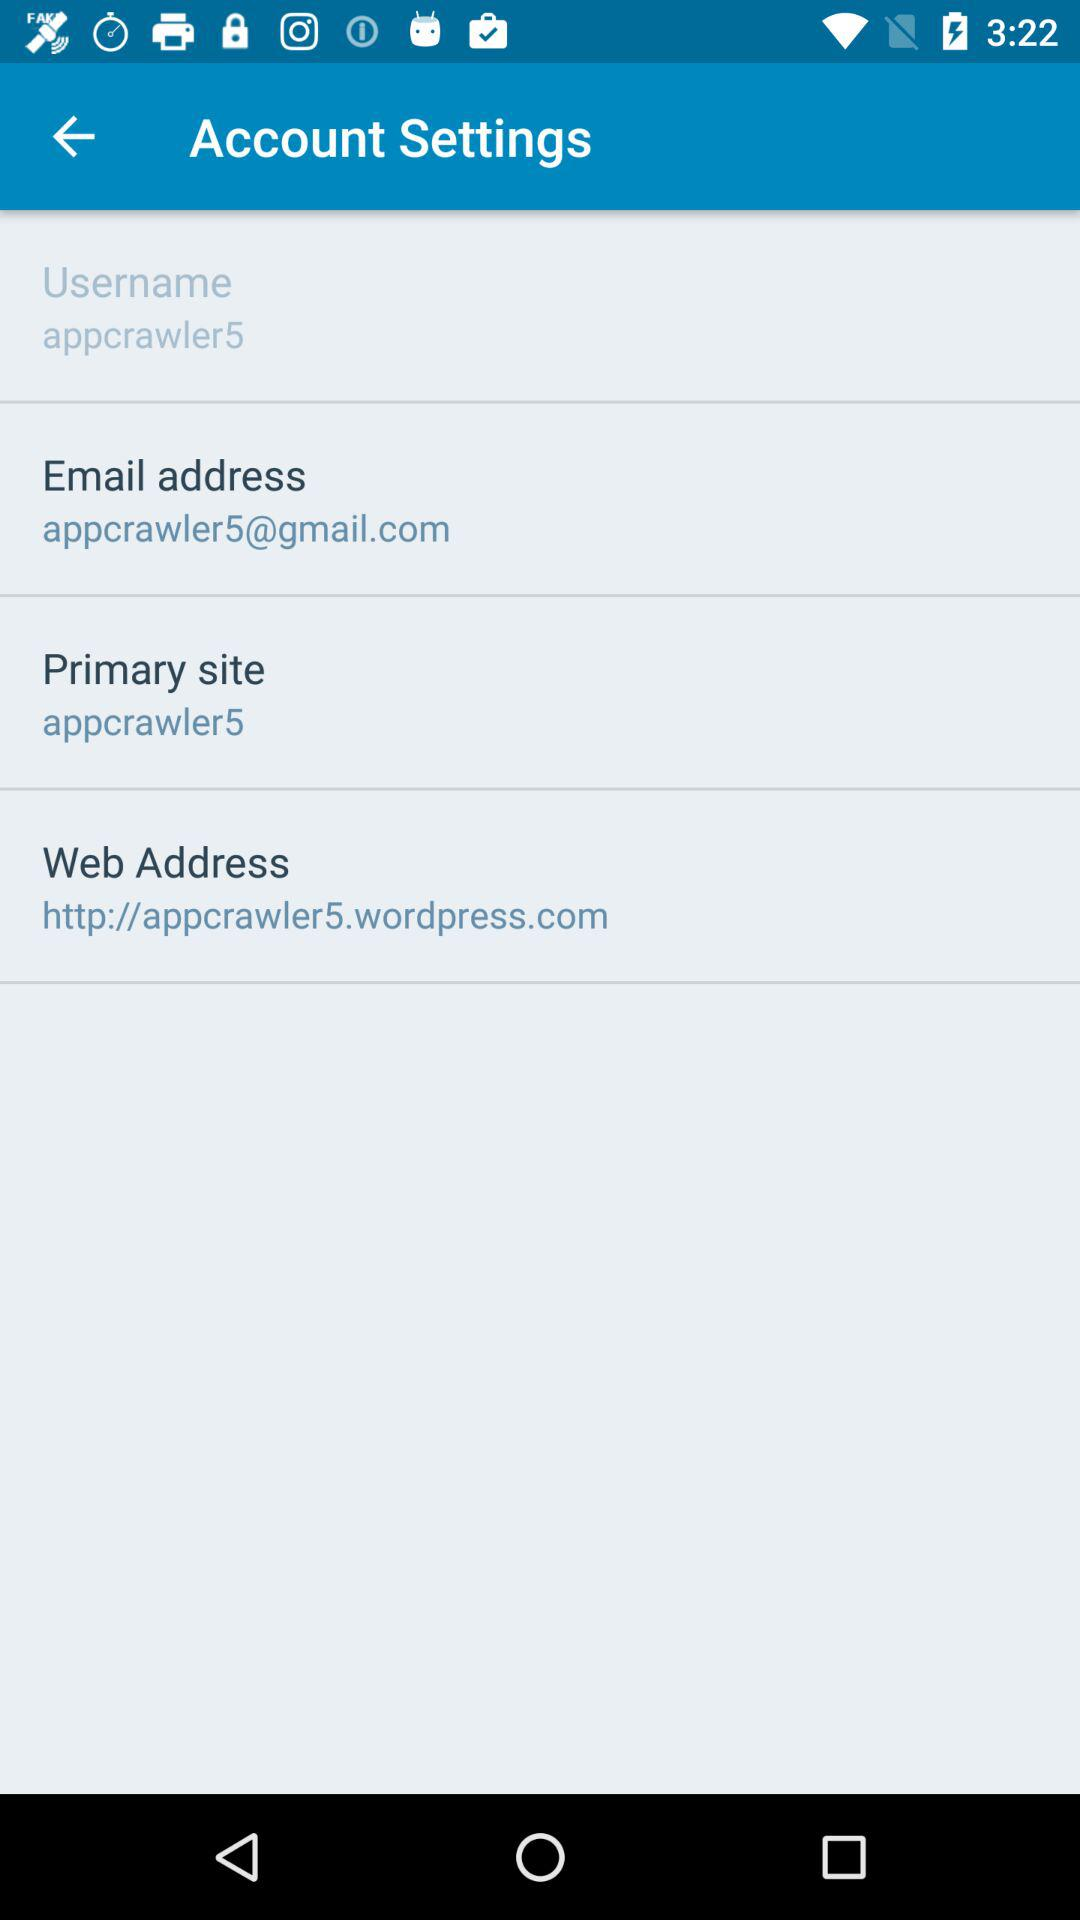When did "appcrawler5" last log in?
When the provided information is insufficient, respond with <no answer>. <no answer> 